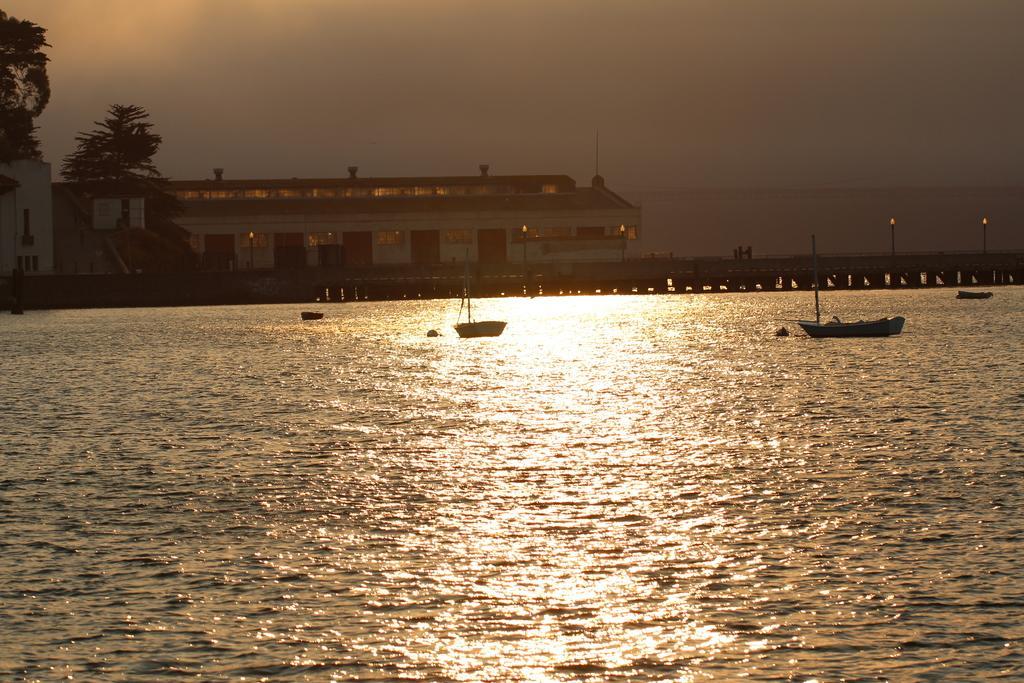Please provide a concise description of this image. In this image we can see a river. On the river there are some boats. In the background of the image there is a building, beside the building there are trees and sky. 